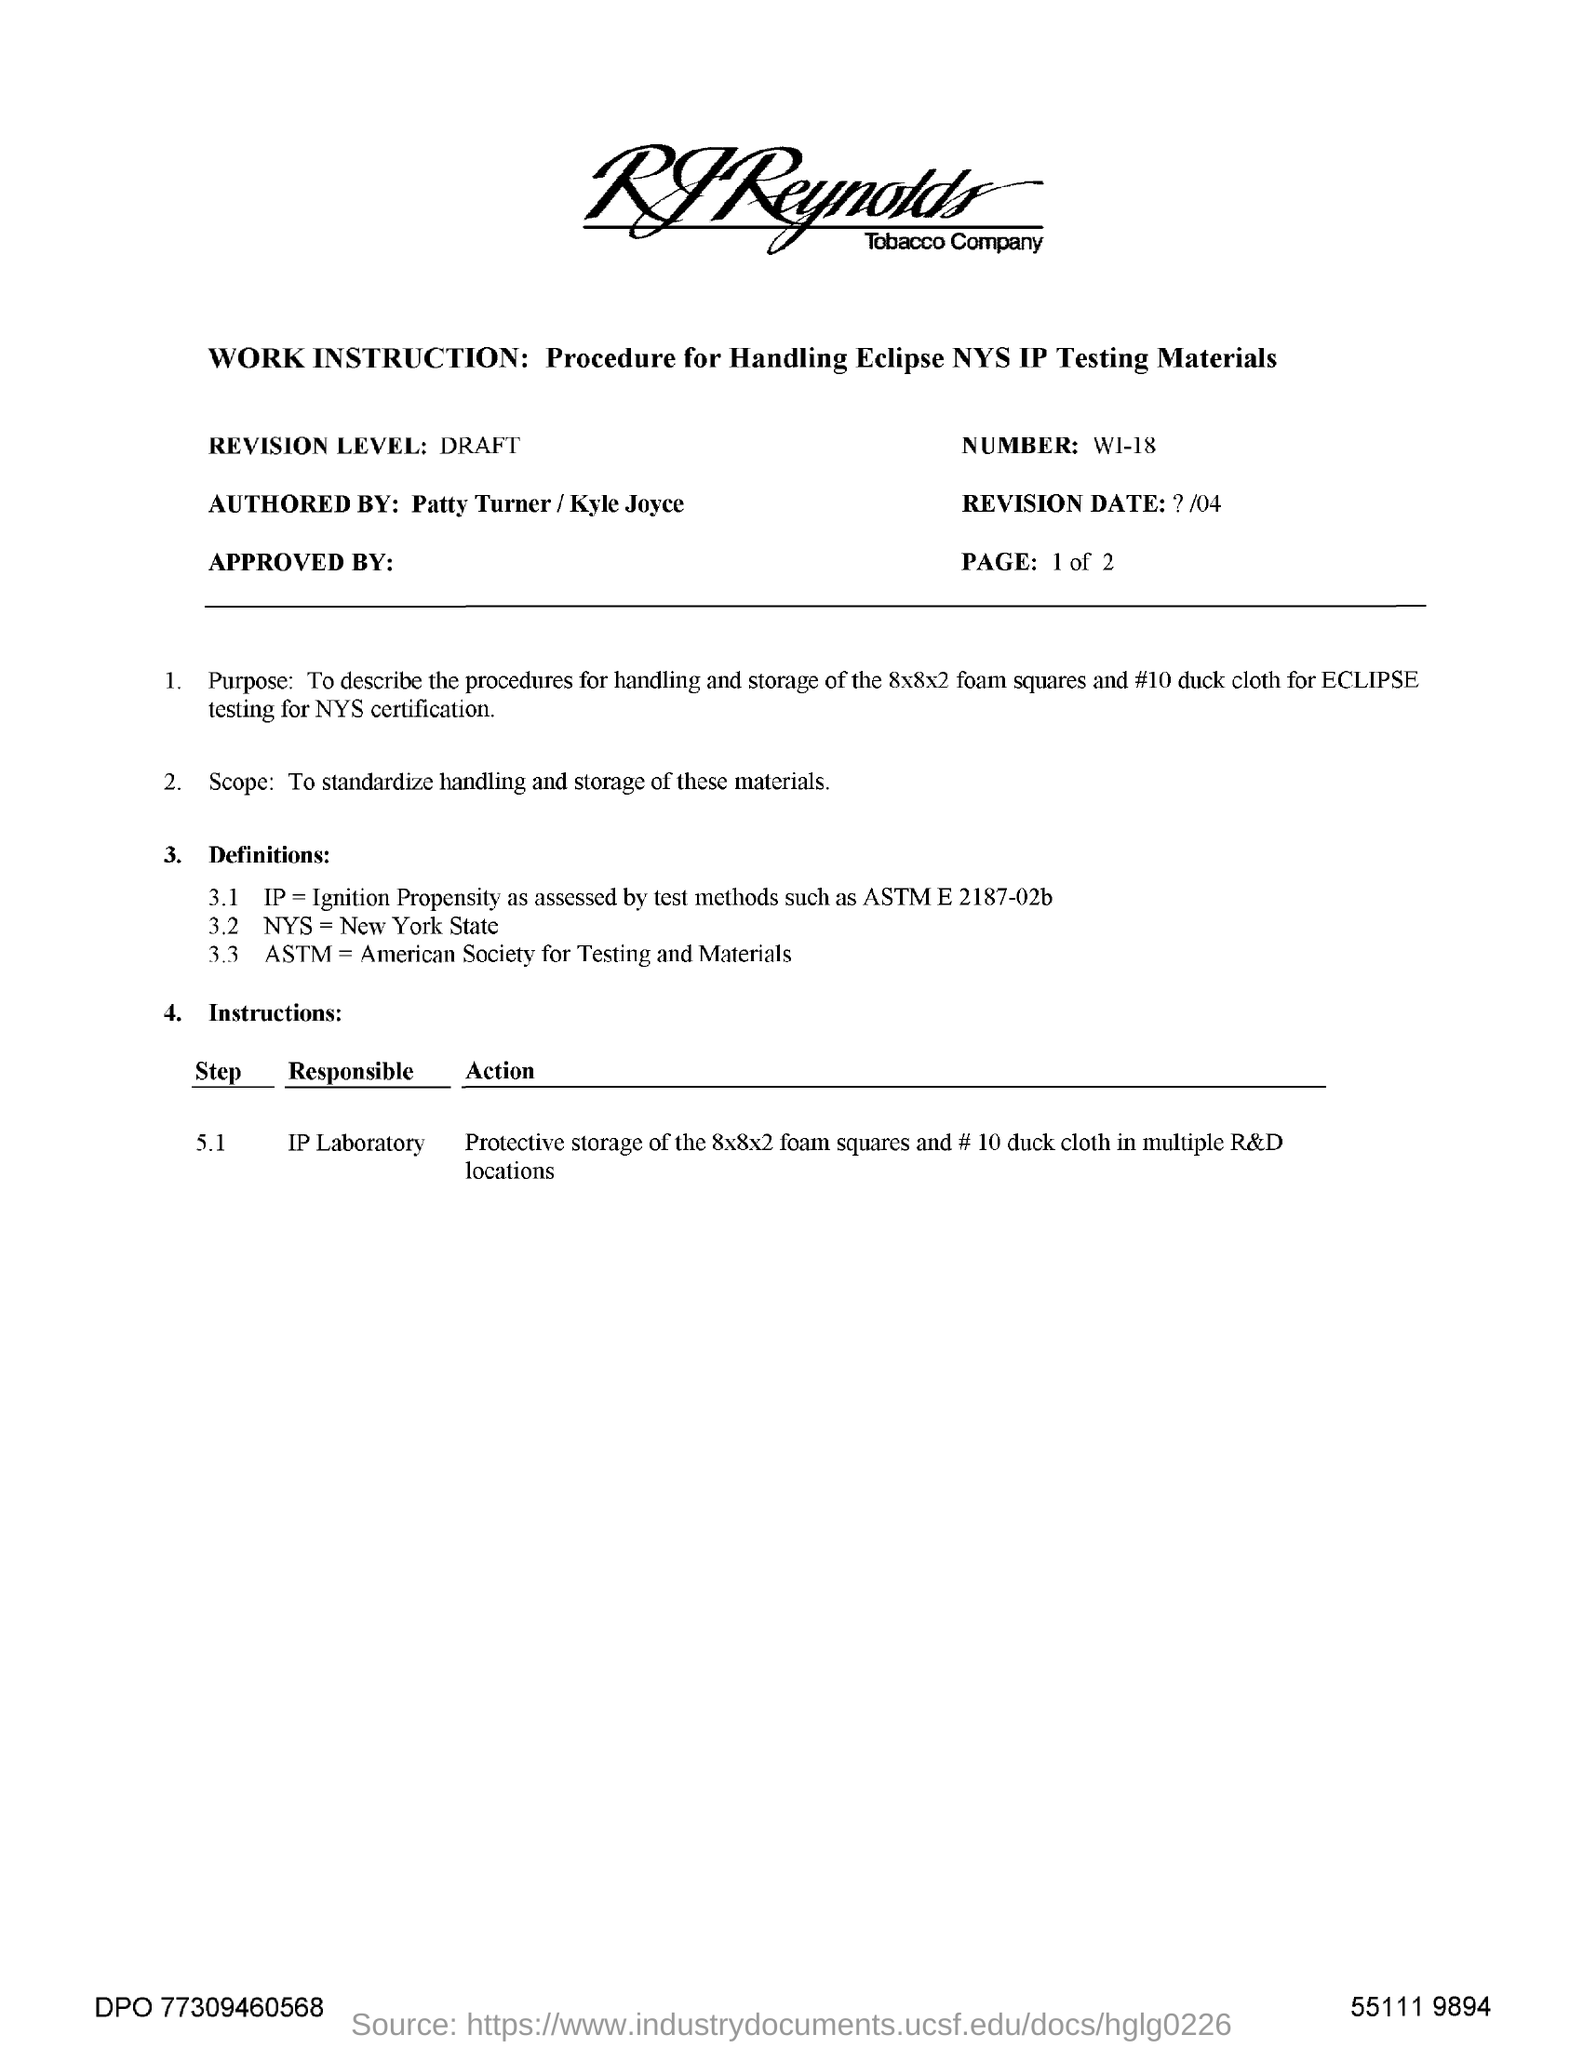Mention a couple of crucial points in this snapshot. I declare that "NYS" stands for New York State. The document mentions a revision level of DRAFT. 